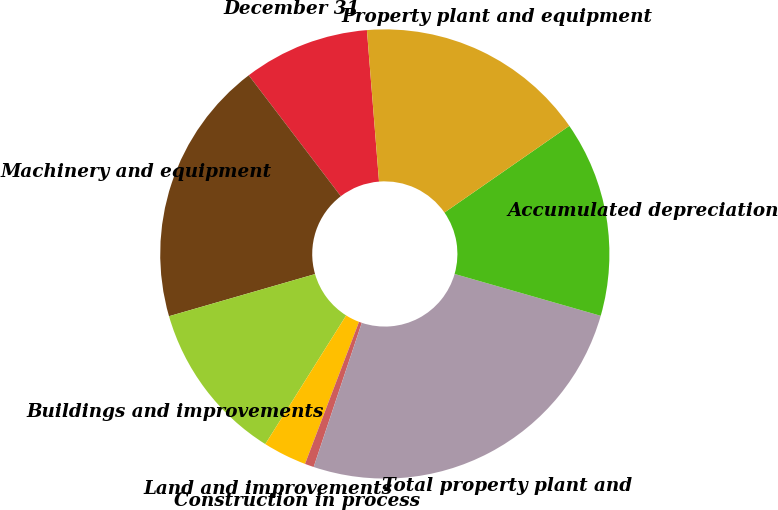<chart> <loc_0><loc_0><loc_500><loc_500><pie_chart><fcel>December 31<fcel>Machinery and equipment<fcel>Buildings and improvements<fcel>Land and improvements<fcel>Construction in process<fcel>Total property plant and<fcel>Accumulated depreciation<fcel>Property plant and equipment<nl><fcel>9.09%<fcel>19.11%<fcel>11.6%<fcel>3.15%<fcel>0.65%<fcel>25.69%<fcel>14.1%<fcel>16.61%<nl></chart> 